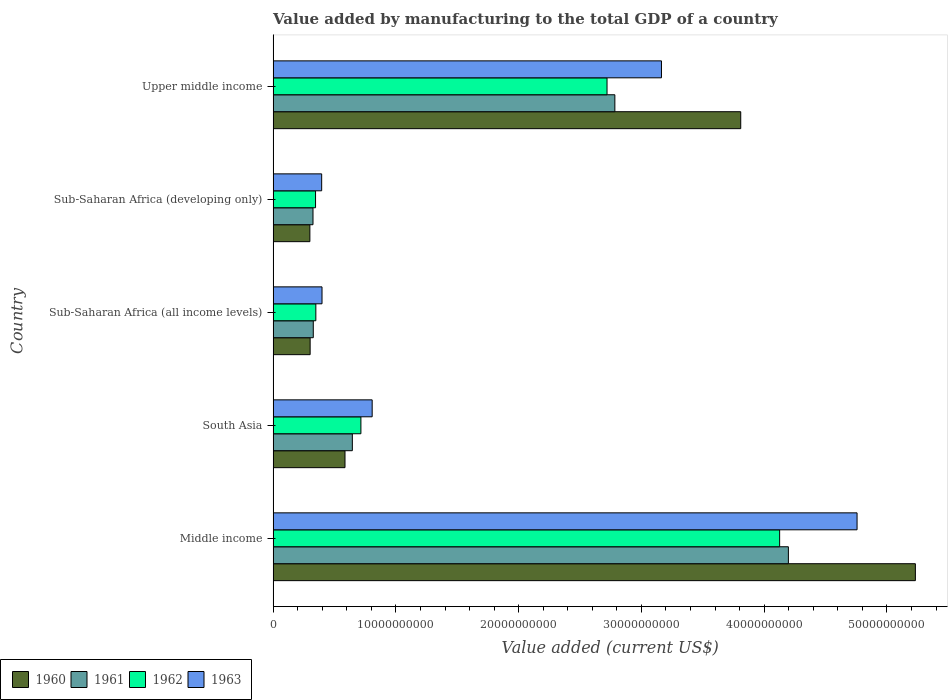Are the number of bars on each tick of the Y-axis equal?
Make the answer very short. Yes. How many bars are there on the 1st tick from the bottom?
Your answer should be very brief. 4. What is the label of the 5th group of bars from the top?
Your answer should be compact. Middle income. In how many cases, is the number of bars for a given country not equal to the number of legend labels?
Give a very brief answer. 0. What is the value added by manufacturing to the total GDP in 1961 in Middle income?
Ensure brevity in your answer.  4.20e+1. Across all countries, what is the maximum value added by manufacturing to the total GDP in 1963?
Give a very brief answer. 4.76e+1. Across all countries, what is the minimum value added by manufacturing to the total GDP in 1963?
Make the answer very short. 3.95e+09. In which country was the value added by manufacturing to the total GDP in 1963 maximum?
Give a very brief answer. Middle income. In which country was the value added by manufacturing to the total GDP in 1962 minimum?
Keep it short and to the point. Sub-Saharan Africa (developing only). What is the total value added by manufacturing to the total GDP in 1961 in the graph?
Your response must be concise. 8.28e+1. What is the difference between the value added by manufacturing to the total GDP in 1960 in Middle income and that in South Asia?
Offer a very short reply. 4.65e+1. What is the difference between the value added by manufacturing to the total GDP in 1963 in South Asia and the value added by manufacturing to the total GDP in 1962 in Middle income?
Your response must be concise. -3.32e+1. What is the average value added by manufacturing to the total GDP in 1960 per country?
Your answer should be very brief. 2.05e+1. What is the difference between the value added by manufacturing to the total GDP in 1963 and value added by manufacturing to the total GDP in 1960 in Sub-Saharan Africa (developing only)?
Offer a very short reply. 9.61e+08. What is the ratio of the value added by manufacturing to the total GDP in 1961 in South Asia to that in Sub-Saharan Africa (all income levels)?
Give a very brief answer. 1.97. What is the difference between the highest and the second highest value added by manufacturing to the total GDP in 1960?
Keep it short and to the point. 1.42e+1. What is the difference between the highest and the lowest value added by manufacturing to the total GDP in 1963?
Provide a succinct answer. 4.36e+1. In how many countries, is the value added by manufacturing to the total GDP in 1960 greater than the average value added by manufacturing to the total GDP in 1960 taken over all countries?
Offer a very short reply. 2. Is the sum of the value added by manufacturing to the total GDP in 1961 in Middle income and Upper middle income greater than the maximum value added by manufacturing to the total GDP in 1963 across all countries?
Offer a terse response. Yes. Is it the case that in every country, the sum of the value added by manufacturing to the total GDP in 1963 and value added by manufacturing to the total GDP in 1960 is greater than the sum of value added by manufacturing to the total GDP in 1961 and value added by manufacturing to the total GDP in 1962?
Make the answer very short. Yes. What does the 1st bar from the top in Sub-Saharan Africa (all income levels) represents?
Provide a succinct answer. 1963. Are all the bars in the graph horizontal?
Ensure brevity in your answer.  Yes. How many countries are there in the graph?
Your answer should be compact. 5. What is the difference between two consecutive major ticks on the X-axis?
Give a very brief answer. 1.00e+1. Does the graph contain any zero values?
Ensure brevity in your answer.  No. Does the graph contain grids?
Your response must be concise. No. Where does the legend appear in the graph?
Keep it short and to the point. Bottom left. How are the legend labels stacked?
Your answer should be compact. Horizontal. What is the title of the graph?
Your answer should be compact. Value added by manufacturing to the total GDP of a country. What is the label or title of the X-axis?
Make the answer very short. Value added (current US$). What is the label or title of the Y-axis?
Your answer should be compact. Country. What is the Value added (current US$) of 1960 in Middle income?
Your answer should be very brief. 5.23e+1. What is the Value added (current US$) in 1961 in Middle income?
Your answer should be compact. 4.20e+1. What is the Value added (current US$) in 1962 in Middle income?
Offer a very short reply. 4.13e+1. What is the Value added (current US$) of 1963 in Middle income?
Make the answer very short. 4.76e+1. What is the Value added (current US$) of 1960 in South Asia?
Keep it short and to the point. 5.86e+09. What is the Value added (current US$) in 1961 in South Asia?
Your response must be concise. 6.45e+09. What is the Value added (current US$) of 1962 in South Asia?
Ensure brevity in your answer.  7.15e+09. What is the Value added (current US$) in 1963 in South Asia?
Keep it short and to the point. 8.07e+09. What is the Value added (current US$) in 1960 in Sub-Saharan Africa (all income levels)?
Ensure brevity in your answer.  3.02e+09. What is the Value added (current US$) of 1961 in Sub-Saharan Africa (all income levels)?
Offer a terse response. 3.27e+09. What is the Value added (current US$) of 1962 in Sub-Saharan Africa (all income levels)?
Provide a succinct answer. 3.48e+09. What is the Value added (current US$) in 1963 in Sub-Saharan Africa (all income levels)?
Offer a very short reply. 3.98e+09. What is the Value added (current US$) of 1960 in Sub-Saharan Africa (developing only)?
Your answer should be very brief. 2.99e+09. What is the Value added (current US$) in 1961 in Sub-Saharan Africa (developing only)?
Ensure brevity in your answer.  3.25e+09. What is the Value added (current US$) in 1962 in Sub-Saharan Africa (developing only)?
Make the answer very short. 3.46e+09. What is the Value added (current US$) of 1963 in Sub-Saharan Africa (developing only)?
Make the answer very short. 3.95e+09. What is the Value added (current US$) of 1960 in Upper middle income?
Offer a very short reply. 3.81e+1. What is the Value added (current US$) of 1961 in Upper middle income?
Provide a short and direct response. 2.78e+1. What is the Value added (current US$) of 1962 in Upper middle income?
Ensure brevity in your answer.  2.72e+1. What is the Value added (current US$) in 1963 in Upper middle income?
Offer a very short reply. 3.16e+1. Across all countries, what is the maximum Value added (current US$) of 1960?
Provide a succinct answer. 5.23e+1. Across all countries, what is the maximum Value added (current US$) of 1961?
Your answer should be very brief. 4.20e+1. Across all countries, what is the maximum Value added (current US$) in 1962?
Your answer should be compact. 4.13e+1. Across all countries, what is the maximum Value added (current US$) in 1963?
Provide a short and direct response. 4.76e+1. Across all countries, what is the minimum Value added (current US$) of 1960?
Provide a succinct answer. 2.99e+09. Across all countries, what is the minimum Value added (current US$) in 1961?
Give a very brief answer. 3.25e+09. Across all countries, what is the minimum Value added (current US$) in 1962?
Your response must be concise. 3.46e+09. Across all countries, what is the minimum Value added (current US$) of 1963?
Provide a short and direct response. 3.95e+09. What is the total Value added (current US$) of 1960 in the graph?
Give a very brief answer. 1.02e+11. What is the total Value added (current US$) of 1961 in the graph?
Ensure brevity in your answer.  8.28e+1. What is the total Value added (current US$) of 1962 in the graph?
Ensure brevity in your answer.  8.25e+1. What is the total Value added (current US$) of 1963 in the graph?
Keep it short and to the point. 9.52e+1. What is the difference between the Value added (current US$) in 1960 in Middle income and that in South Asia?
Give a very brief answer. 4.65e+1. What is the difference between the Value added (current US$) in 1961 in Middle income and that in South Asia?
Your response must be concise. 3.55e+1. What is the difference between the Value added (current US$) of 1962 in Middle income and that in South Asia?
Offer a very short reply. 3.41e+1. What is the difference between the Value added (current US$) in 1963 in Middle income and that in South Asia?
Offer a very short reply. 3.95e+1. What is the difference between the Value added (current US$) in 1960 in Middle income and that in Sub-Saharan Africa (all income levels)?
Provide a succinct answer. 4.93e+1. What is the difference between the Value added (current US$) in 1961 in Middle income and that in Sub-Saharan Africa (all income levels)?
Offer a very short reply. 3.87e+1. What is the difference between the Value added (current US$) in 1962 in Middle income and that in Sub-Saharan Africa (all income levels)?
Ensure brevity in your answer.  3.78e+1. What is the difference between the Value added (current US$) of 1963 in Middle income and that in Sub-Saharan Africa (all income levels)?
Give a very brief answer. 4.36e+1. What is the difference between the Value added (current US$) of 1960 in Middle income and that in Sub-Saharan Africa (developing only)?
Offer a terse response. 4.93e+1. What is the difference between the Value added (current US$) in 1961 in Middle income and that in Sub-Saharan Africa (developing only)?
Make the answer very short. 3.87e+1. What is the difference between the Value added (current US$) of 1962 in Middle income and that in Sub-Saharan Africa (developing only)?
Make the answer very short. 3.78e+1. What is the difference between the Value added (current US$) in 1963 in Middle income and that in Sub-Saharan Africa (developing only)?
Your answer should be very brief. 4.36e+1. What is the difference between the Value added (current US$) of 1960 in Middle income and that in Upper middle income?
Provide a succinct answer. 1.42e+1. What is the difference between the Value added (current US$) in 1961 in Middle income and that in Upper middle income?
Your answer should be very brief. 1.41e+1. What is the difference between the Value added (current US$) in 1962 in Middle income and that in Upper middle income?
Ensure brevity in your answer.  1.41e+1. What is the difference between the Value added (current US$) of 1963 in Middle income and that in Upper middle income?
Offer a very short reply. 1.59e+1. What is the difference between the Value added (current US$) of 1960 in South Asia and that in Sub-Saharan Africa (all income levels)?
Your answer should be compact. 2.84e+09. What is the difference between the Value added (current US$) in 1961 in South Asia and that in Sub-Saharan Africa (all income levels)?
Your response must be concise. 3.18e+09. What is the difference between the Value added (current US$) of 1962 in South Asia and that in Sub-Saharan Africa (all income levels)?
Ensure brevity in your answer.  3.67e+09. What is the difference between the Value added (current US$) in 1963 in South Asia and that in Sub-Saharan Africa (all income levels)?
Your answer should be compact. 4.08e+09. What is the difference between the Value added (current US$) in 1960 in South Asia and that in Sub-Saharan Africa (developing only)?
Keep it short and to the point. 2.86e+09. What is the difference between the Value added (current US$) of 1961 in South Asia and that in Sub-Saharan Africa (developing only)?
Keep it short and to the point. 3.21e+09. What is the difference between the Value added (current US$) of 1962 in South Asia and that in Sub-Saharan Africa (developing only)?
Provide a short and direct response. 3.70e+09. What is the difference between the Value added (current US$) of 1963 in South Asia and that in Sub-Saharan Africa (developing only)?
Offer a very short reply. 4.11e+09. What is the difference between the Value added (current US$) in 1960 in South Asia and that in Upper middle income?
Make the answer very short. -3.22e+1. What is the difference between the Value added (current US$) in 1961 in South Asia and that in Upper middle income?
Provide a short and direct response. -2.14e+1. What is the difference between the Value added (current US$) of 1962 in South Asia and that in Upper middle income?
Your answer should be very brief. -2.00e+1. What is the difference between the Value added (current US$) in 1963 in South Asia and that in Upper middle income?
Your response must be concise. -2.36e+1. What is the difference between the Value added (current US$) of 1960 in Sub-Saharan Africa (all income levels) and that in Sub-Saharan Africa (developing only)?
Ensure brevity in your answer.  2.16e+07. What is the difference between the Value added (current US$) of 1961 in Sub-Saharan Africa (all income levels) and that in Sub-Saharan Africa (developing only)?
Keep it short and to the point. 2.34e+07. What is the difference between the Value added (current US$) in 1962 in Sub-Saharan Africa (all income levels) and that in Sub-Saharan Africa (developing only)?
Keep it short and to the point. 2.49e+07. What is the difference between the Value added (current US$) of 1963 in Sub-Saharan Africa (all income levels) and that in Sub-Saharan Africa (developing only)?
Your response must be concise. 2.85e+07. What is the difference between the Value added (current US$) of 1960 in Sub-Saharan Africa (all income levels) and that in Upper middle income?
Ensure brevity in your answer.  -3.51e+1. What is the difference between the Value added (current US$) of 1961 in Sub-Saharan Africa (all income levels) and that in Upper middle income?
Offer a very short reply. -2.46e+1. What is the difference between the Value added (current US$) in 1962 in Sub-Saharan Africa (all income levels) and that in Upper middle income?
Ensure brevity in your answer.  -2.37e+1. What is the difference between the Value added (current US$) of 1963 in Sub-Saharan Africa (all income levels) and that in Upper middle income?
Give a very brief answer. -2.76e+1. What is the difference between the Value added (current US$) in 1960 in Sub-Saharan Africa (developing only) and that in Upper middle income?
Your answer should be compact. -3.51e+1. What is the difference between the Value added (current US$) in 1961 in Sub-Saharan Africa (developing only) and that in Upper middle income?
Offer a terse response. -2.46e+1. What is the difference between the Value added (current US$) of 1962 in Sub-Saharan Africa (developing only) and that in Upper middle income?
Your response must be concise. -2.37e+1. What is the difference between the Value added (current US$) of 1963 in Sub-Saharan Africa (developing only) and that in Upper middle income?
Offer a very short reply. -2.77e+1. What is the difference between the Value added (current US$) in 1960 in Middle income and the Value added (current US$) in 1961 in South Asia?
Make the answer very short. 4.59e+1. What is the difference between the Value added (current US$) in 1960 in Middle income and the Value added (current US$) in 1962 in South Asia?
Keep it short and to the point. 4.52e+1. What is the difference between the Value added (current US$) of 1960 in Middle income and the Value added (current US$) of 1963 in South Asia?
Your answer should be very brief. 4.42e+1. What is the difference between the Value added (current US$) in 1961 in Middle income and the Value added (current US$) in 1962 in South Asia?
Provide a short and direct response. 3.48e+1. What is the difference between the Value added (current US$) in 1961 in Middle income and the Value added (current US$) in 1963 in South Asia?
Provide a succinct answer. 3.39e+1. What is the difference between the Value added (current US$) in 1962 in Middle income and the Value added (current US$) in 1963 in South Asia?
Your answer should be very brief. 3.32e+1. What is the difference between the Value added (current US$) in 1960 in Middle income and the Value added (current US$) in 1961 in Sub-Saharan Africa (all income levels)?
Provide a short and direct response. 4.90e+1. What is the difference between the Value added (current US$) of 1960 in Middle income and the Value added (current US$) of 1962 in Sub-Saharan Africa (all income levels)?
Give a very brief answer. 4.88e+1. What is the difference between the Value added (current US$) in 1960 in Middle income and the Value added (current US$) in 1963 in Sub-Saharan Africa (all income levels)?
Give a very brief answer. 4.83e+1. What is the difference between the Value added (current US$) in 1961 in Middle income and the Value added (current US$) in 1962 in Sub-Saharan Africa (all income levels)?
Your answer should be compact. 3.85e+1. What is the difference between the Value added (current US$) of 1961 in Middle income and the Value added (current US$) of 1963 in Sub-Saharan Africa (all income levels)?
Make the answer very short. 3.80e+1. What is the difference between the Value added (current US$) of 1962 in Middle income and the Value added (current US$) of 1963 in Sub-Saharan Africa (all income levels)?
Your answer should be compact. 3.73e+1. What is the difference between the Value added (current US$) in 1960 in Middle income and the Value added (current US$) in 1961 in Sub-Saharan Africa (developing only)?
Give a very brief answer. 4.91e+1. What is the difference between the Value added (current US$) in 1960 in Middle income and the Value added (current US$) in 1962 in Sub-Saharan Africa (developing only)?
Your response must be concise. 4.89e+1. What is the difference between the Value added (current US$) in 1960 in Middle income and the Value added (current US$) in 1963 in Sub-Saharan Africa (developing only)?
Make the answer very short. 4.84e+1. What is the difference between the Value added (current US$) in 1961 in Middle income and the Value added (current US$) in 1962 in Sub-Saharan Africa (developing only)?
Offer a terse response. 3.85e+1. What is the difference between the Value added (current US$) in 1961 in Middle income and the Value added (current US$) in 1963 in Sub-Saharan Africa (developing only)?
Offer a terse response. 3.80e+1. What is the difference between the Value added (current US$) of 1962 in Middle income and the Value added (current US$) of 1963 in Sub-Saharan Africa (developing only)?
Provide a succinct answer. 3.73e+1. What is the difference between the Value added (current US$) of 1960 in Middle income and the Value added (current US$) of 1961 in Upper middle income?
Provide a short and direct response. 2.45e+1. What is the difference between the Value added (current US$) of 1960 in Middle income and the Value added (current US$) of 1962 in Upper middle income?
Offer a terse response. 2.51e+1. What is the difference between the Value added (current US$) in 1960 in Middle income and the Value added (current US$) in 1963 in Upper middle income?
Give a very brief answer. 2.07e+1. What is the difference between the Value added (current US$) of 1961 in Middle income and the Value added (current US$) of 1962 in Upper middle income?
Keep it short and to the point. 1.48e+1. What is the difference between the Value added (current US$) of 1961 in Middle income and the Value added (current US$) of 1963 in Upper middle income?
Offer a terse response. 1.03e+1. What is the difference between the Value added (current US$) of 1962 in Middle income and the Value added (current US$) of 1963 in Upper middle income?
Provide a succinct answer. 9.63e+09. What is the difference between the Value added (current US$) in 1960 in South Asia and the Value added (current US$) in 1961 in Sub-Saharan Africa (all income levels)?
Make the answer very short. 2.58e+09. What is the difference between the Value added (current US$) of 1960 in South Asia and the Value added (current US$) of 1962 in Sub-Saharan Africa (all income levels)?
Keep it short and to the point. 2.37e+09. What is the difference between the Value added (current US$) of 1960 in South Asia and the Value added (current US$) of 1963 in Sub-Saharan Africa (all income levels)?
Your answer should be very brief. 1.87e+09. What is the difference between the Value added (current US$) in 1961 in South Asia and the Value added (current US$) in 1962 in Sub-Saharan Africa (all income levels)?
Make the answer very short. 2.97e+09. What is the difference between the Value added (current US$) in 1961 in South Asia and the Value added (current US$) in 1963 in Sub-Saharan Africa (all income levels)?
Your response must be concise. 2.47e+09. What is the difference between the Value added (current US$) of 1962 in South Asia and the Value added (current US$) of 1963 in Sub-Saharan Africa (all income levels)?
Give a very brief answer. 3.17e+09. What is the difference between the Value added (current US$) of 1960 in South Asia and the Value added (current US$) of 1961 in Sub-Saharan Africa (developing only)?
Make the answer very short. 2.61e+09. What is the difference between the Value added (current US$) of 1960 in South Asia and the Value added (current US$) of 1962 in Sub-Saharan Africa (developing only)?
Provide a succinct answer. 2.40e+09. What is the difference between the Value added (current US$) in 1960 in South Asia and the Value added (current US$) in 1963 in Sub-Saharan Africa (developing only)?
Provide a short and direct response. 1.90e+09. What is the difference between the Value added (current US$) of 1961 in South Asia and the Value added (current US$) of 1962 in Sub-Saharan Africa (developing only)?
Offer a very short reply. 3.00e+09. What is the difference between the Value added (current US$) in 1961 in South Asia and the Value added (current US$) in 1963 in Sub-Saharan Africa (developing only)?
Offer a terse response. 2.50e+09. What is the difference between the Value added (current US$) in 1962 in South Asia and the Value added (current US$) in 1963 in Sub-Saharan Africa (developing only)?
Offer a very short reply. 3.20e+09. What is the difference between the Value added (current US$) in 1960 in South Asia and the Value added (current US$) in 1961 in Upper middle income?
Offer a very short reply. -2.20e+1. What is the difference between the Value added (current US$) of 1960 in South Asia and the Value added (current US$) of 1962 in Upper middle income?
Ensure brevity in your answer.  -2.13e+1. What is the difference between the Value added (current US$) in 1960 in South Asia and the Value added (current US$) in 1963 in Upper middle income?
Keep it short and to the point. -2.58e+1. What is the difference between the Value added (current US$) of 1961 in South Asia and the Value added (current US$) of 1962 in Upper middle income?
Provide a short and direct response. -2.07e+1. What is the difference between the Value added (current US$) in 1961 in South Asia and the Value added (current US$) in 1963 in Upper middle income?
Your response must be concise. -2.52e+1. What is the difference between the Value added (current US$) in 1962 in South Asia and the Value added (current US$) in 1963 in Upper middle income?
Keep it short and to the point. -2.45e+1. What is the difference between the Value added (current US$) of 1960 in Sub-Saharan Africa (all income levels) and the Value added (current US$) of 1961 in Sub-Saharan Africa (developing only)?
Offer a very short reply. -2.32e+08. What is the difference between the Value added (current US$) of 1960 in Sub-Saharan Africa (all income levels) and the Value added (current US$) of 1962 in Sub-Saharan Africa (developing only)?
Give a very brief answer. -4.40e+08. What is the difference between the Value added (current US$) in 1960 in Sub-Saharan Africa (all income levels) and the Value added (current US$) in 1963 in Sub-Saharan Africa (developing only)?
Your answer should be compact. -9.39e+08. What is the difference between the Value added (current US$) of 1961 in Sub-Saharan Africa (all income levels) and the Value added (current US$) of 1962 in Sub-Saharan Africa (developing only)?
Your response must be concise. -1.85e+08. What is the difference between the Value added (current US$) of 1961 in Sub-Saharan Africa (all income levels) and the Value added (current US$) of 1963 in Sub-Saharan Africa (developing only)?
Your answer should be compact. -6.84e+08. What is the difference between the Value added (current US$) of 1962 in Sub-Saharan Africa (all income levels) and the Value added (current US$) of 1963 in Sub-Saharan Africa (developing only)?
Keep it short and to the point. -4.74e+08. What is the difference between the Value added (current US$) of 1960 in Sub-Saharan Africa (all income levels) and the Value added (current US$) of 1961 in Upper middle income?
Provide a succinct answer. -2.48e+1. What is the difference between the Value added (current US$) in 1960 in Sub-Saharan Africa (all income levels) and the Value added (current US$) in 1962 in Upper middle income?
Your answer should be very brief. -2.42e+1. What is the difference between the Value added (current US$) in 1960 in Sub-Saharan Africa (all income levels) and the Value added (current US$) in 1963 in Upper middle income?
Ensure brevity in your answer.  -2.86e+1. What is the difference between the Value added (current US$) in 1961 in Sub-Saharan Africa (all income levels) and the Value added (current US$) in 1962 in Upper middle income?
Your answer should be compact. -2.39e+1. What is the difference between the Value added (current US$) in 1961 in Sub-Saharan Africa (all income levels) and the Value added (current US$) in 1963 in Upper middle income?
Give a very brief answer. -2.84e+1. What is the difference between the Value added (current US$) of 1962 in Sub-Saharan Africa (all income levels) and the Value added (current US$) of 1963 in Upper middle income?
Offer a terse response. -2.82e+1. What is the difference between the Value added (current US$) of 1960 in Sub-Saharan Africa (developing only) and the Value added (current US$) of 1961 in Upper middle income?
Offer a very short reply. -2.48e+1. What is the difference between the Value added (current US$) of 1960 in Sub-Saharan Africa (developing only) and the Value added (current US$) of 1962 in Upper middle income?
Your response must be concise. -2.42e+1. What is the difference between the Value added (current US$) in 1960 in Sub-Saharan Africa (developing only) and the Value added (current US$) in 1963 in Upper middle income?
Keep it short and to the point. -2.86e+1. What is the difference between the Value added (current US$) in 1961 in Sub-Saharan Africa (developing only) and the Value added (current US$) in 1962 in Upper middle income?
Offer a very short reply. -2.40e+1. What is the difference between the Value added (current US$) in 1961 in Sub-Saharan Africa (developing only) and the Value added (current US$) in 1963 in Upper middle income?
Your answer should be compact. -2.84e+1. What is the difference between the Value added (current US$) of 1962 in Sub-Saharan Africa (developing only) and the Value added (current US$) of 1963 in Upper middle income?
Offer a very short reply. -2.82e+1. What is the average Value added (current US$) of 1960 per country?
Provide a succinct answer. 2.05e+1. What is the average Value added (current US$) in 1961 per country?
Offer a very short reply. 1.66e+1. What is the average Value added (current US$) of 1962 per country?
Provide a succinct answer. 1.65e+1. What is the average Value added (current US$) in 1963 per country?
Offer a terse response. 1.90e+1. What is the difference between the Value added (current US$) of 1960 and Value added (current US$) of 1961 in Middle income?
Your response must be concise. 1.03e+1. What is the difference between the Value added (current US$) of 1960 and Value added (current US$) of 1962 in Middle income?
Your answer should be very brief. 1.11e+1. What is the difference between the Value added (current US$) in 1960 and Value added (current US$) in 1963 in Middle income?
Ensure brevity in your answer.  4.75e+09. What is the difference between the Value added (current US$) of 1961 and Value added (current US$) of 1962 in Middle income?
Your answer should be compact. 7.12e+08. What is the difference between the Value added (current US$) of 1961 and Value added (current US$) of 1963 in Middle income?
Ensure brevity in your answer.  -5.59e+09. What is the difference between the Value added (current US$) of 1962 and Value added (current US$) of 1963 in Middle income?
Offer a very short reply. -6.31e+09. What is the difference between the Value added (current US$) of 1960 and Value added (current US$) of 1961 in South Asia?
Your answer should be compact. -5.98e+08. What is the difference between the Value added (current US$) in 1960 and Value added (current US$) in 1962 in South Asia?
Make the answer very short. -1.30e+09. What is the difference between the Value added (current US$) of 1960 and Value added (current US$) of 1963 in South Asia?
Your answer should be very brief. -2.21e+09. What is the difference between the Value added (current US$) of 1961 and Value added (current US$) of 1962 in South Asia?
Your answer should be very brief. -6.98e+08. What is the difference between the Value added (current US$) in 1961 and Value added (current US$) in 1963 in South Asia?
Your response must be concise. -1.61e+09. What is the difference between the Value added (current US$) of 1962 and Value added (current US$) of 1963 in South Asia?
Provide a succinct answer. -9.17e+08. What is the difference between the Value added (current US$) in 1960 and Value added (current US$) in 1961 in Sub-Saharan Africa (all income levels)?
Your answer should be very brief. -2.55e+08. What is the difference between the Value added (current US$) in 1960 and Value added (current US$) in 1962 in Sub-Saharan Africa (all income levels)?
Your response must be concise. -4.65e+08. What is the difference between the Value added (current US$) of 1960 and Value added (current US$) of 1963 in Sub-Saharan Africa (all income levels)?
Offer a very short reply. -9.68e+08. What is the difference between the Value added (current US$) of 1961 and Value added (current US$) of 1962 in Sub-Saharan Africa (all income levels)?
Give a very brief answer. -2.09e+08. What is the difference between the Value added (current US$) in 1961 and Value added (current US$) in 1963 in Sub-Saharan Africa (all income levels)?
Provide a succinct answer. -7.12e+08. What is the difference between the Value added (current US$) of 1962 and Value added (current US$) of 1963 in Sub-Saharan Africa (all income levels)?
Make the answer very short. -5.03e+08. What is the difference between the Value added (current US$) in 1960 and Value added (current US$) in 1961 in Sub-Saharan Africa (developing only)?
Offer a very short reply. -2.54e+08. What is the difference between the Value added (current US$) of 1960 and Value added (current US$) of 1962 in Sub-Saharan Africa (developing only)?
Provide a short and direct response. -4.61e+08. What is the difference between the Value added (current US$) in 1960 and Value added (current US$) in 1963 in Sub-Saharan Africa (developing only)?
Keep it short and to the point. -9.61e+08. What is the difference between the Value added (current US$) of 1961 and Value added (current US$) of 1962 in Sub-Saharan Africa (developing only)?
Your answer should be compact. -2.08e+08. What is the difference between the Value added (current US$) of 1961 and Value added (current US$) of 1963 in Sub-Saharan Africa (developing only)?
Ensure brevity in your answer.  -7.07e+08. What is the difference between the Value added (current US$) in 1962 and Value added (current US$) in 1963 in Sub-Saharan Africa (developing only)?
Offer a very short reply. -4.99e+08. What is the difference between the Value added (current US$) in 1960 and Value added (current US$) in 1961 in Upper middle income?
Keep it short and to the point. 1.03e+1. What is the difference between the Value added (current US$) of 1960 and Value added (current US$) of 1962 in Upper middle income?
Your response must be concise. 1.09e+1. What is the difference between the Value added (current US$) in 1960 and Value added (current US$) in 1963 in Upper middle income?
Offer a very short reply. 6.46e+09. What is the difference between the Value added (current US$) of 1961 and Value added (current US$) of 1962 in Upper middle income?
Keep it short and to the point. 6.38e+08. What is the difference between the Value added (current US$) in 1961 and Value added (current US$) in 1963 in Upper middle income?
Your response must be concise. -3.80e+09. What is the difference between the Value added (current US$) of 1962 and Value added (current US$) of 1963 in Upper middle income?
Your answer should be compact. -4.43e+09. What is the ratio of the Value added (current US$) in 1960 in Middle income to that in South Asia?
Your response must be concise. 8.93. What is the ratio of the Value added (current US$) in 1961 in Middle income to that in South Asia?
Ensure brevity in your answer.  6.5. What is the ratio of the Value added (current US$) of 1962 in Middle income to that in South Asia?
Offer a very short reply. 5.77. What is the ratio of the Value added (current US$) in 1963 in Middle income to that in South Asia?
Your answer should be very brief. 5.9. What is the ratio of the Value added (current US$) of 1960 in Middle income to that in Sub-Saharan Africa (all income levels)?
Provide a succinct answer. 17.35. What is the ratio of the Value added (current US$) of 1961 in Middle income to that in Sub-Saharan Africa (all income levels)?
Provide a short and direct response. 12.83. What is the ratio of the Value added (current US$) of 1962 in Middle income to that in Sub-Saharan Africa (all income levels)?
Your response must be concise. 11.85. What is the ratio of the Value added (current US$) in 1963 in Middle income to that in Sub-Saharan Africa (all income levels)?
Offer a very short reply. 11.94. What is the ratio of the Value added (current US$) of 1960 in Middle income to that in Sub-Saharan Africa (developing only)?
Offer a very short reply. 17.47. What is the ratio of the Value added (current US$) in 1961 in Middle income to that in Sub-Saharan Africa (developing only)?
Your answer should be compact. 12.92. What is the ratio of the Value added (current US$) in 1962 in Middle income to that in Sub-Saharan Africa (developing only)?
Offer a very short reply. 11.94. What is the ratio of the Value added (current US$) in 1963 in Middle income to that in Sub-Saharan Africa (developing only)?
Offer a terse response. 12.03. What is the ratio of the Value added (current US$) in 1960 in Middle income to that in Upper middle income?
Give a very brief answer. 1.37. What is the ratio of the Value added (current US$) in 1961 in Middle income to that in Upper middle income?
Keep it short and to the point. 1.51. What is the ratio of the Value added (current US$) in 1962 in Middle income to that in Upper middle income?
Your answer should be very brief. 1.52. What is the ratio of the Value added (current US$) of 1963 in Middle income to that in Upper middle income?
Offer a very short reply. 1.5. What is the ratio of the Value added (current US$) in 1960 in South Asia to that in Sub-Saharan Africa (all income levels)?
Offer a very short reply. 1.94. What is the ratio of the Value added (current US$) of 1961 in South Asia to that in Sub-Saharan Africa (all income levels)?
Offer a terse response. 1.97. What is the ratio of the Value added (current US$) of 1962 in South Asia to that in Sub-Saharan Africa (all income levels)?
Keep it short and to the point. 2.05. What is the ratio of the Value added (current US$) in 1963 in South Asia to that in Sub-Saharan Africa (all income levels)?
Your answer should be very brief. 2.03. What is the ratio of the Value added (current US$) in 1960 in South Asia to that in Sub-Saharan Africa (developing only)?
Give a very brief answer. 1.96. What is the ratio of the Value added (current US$) of 1961 in South Asia to that in Sub-Saharan Africa (developing only)?
Your answer should be compact. 1.99. What is the ratio of the Value added (current US$) of 1962 in South Asia to that in Sub-Saharan Africa (developing only)?
Your answer should be compact. 2.07. What is the ratio of the Value added (current US$) of 1963 in South Asia to that in Sub-Saharan Africa (developing only)?
Your answer should be compact. 2.04. What is the ratio of the Value added (current US$) of 1960 in South Asia to that in Upper middle income?
Make the answer very short. 0.15. What is the ratio of the Value added (current US$) in 1961 in South Asia to that in Upper middle income?
Offer a terse response. 0.23. What is the ratio of the Value added (current US$) of 1962 in South Asia to that in Upper middle income?
Your answer should be compact. 0.26. What is the ratio of the Value added (current US$) in 1963 in South Asia to that in Upper middle income?
Your response must be concise. 0.26. What is the ratio of the Value added (current US$) of 1962 in Sub-Saharan Africa (all income levels) to that in Sub-Saharan Africa (developing only)?
Make the answer very short. 1.01. What is the ratio of the Value added (current US$) of 1960 in Sub-Saharan Africa (all income levels) to that in Upper middle income?
Provide a short and direct response. 0.08. What is the ratio of the Value added (current US$) of 1961 in Sub-Saharan Africa (all income levels) to that in Upper middle income?
Offer a terse response. 0.12. What is the ratio of the Value added (current US$) in 1962 in Sub-Saharan Africa (all income levels) to that in Upper middle income?
Make the answer very short. 0.13. What is the ratio of the Value added (current US$) of 1963 in Sub-Saharan Africa (all income levels) to that in Upper middle income?
Provide a succinct answer. 0.13. What is the ratio of the Value added (current US$) of 1960 in Sub-Saharan Africa (developing only) to that in Upper middle income?
Offer a very short reply. 0.08. What is the ratio of the Value added (current US$) of 1961 in Sub-Saharan Africa (developing only) to that in Upper middle income?
Your response must be concise. 0.12. What is the ratio of the Value added (current US$) in 1962 in Sub-Saharan Africa (developing only) to that in Upper middle income?
Provide a short and direct response. 0.13. What is the difference between the highest and the second highest Value added (current US$) in 1960?
Ensure brevity in your answer.  1.42e+1. What is the difference between the highest and the second highest Value added (current US$) of 1961?
Provide a short and direct response. 1.41e+1. What is the difference between the highest and the second highest Value added (current US$) of 1962?
Keep it short and to the point. 1.41e+1. What is the difference between the highest and the second highest Value added (current US$) of 1963?
Offer a very short reply. 1.59e+1. What is the difference between the highest and the lowest Value added (current US$) in 1960?
Keep it short and to the point. 4.93e+1. What is the difference between the highest and the lowest Value added (current US$) of 1961?
Your answer should be compact. 3.87e+1. What is the difference between the highest and the lowest Value added (current US$) of 1962?
Make the answer very short. 3.78e+1. What is the difference between the highest and the lowest Value added (current US$) of 1963?
Give a very brief answer. 4.36e+1. 